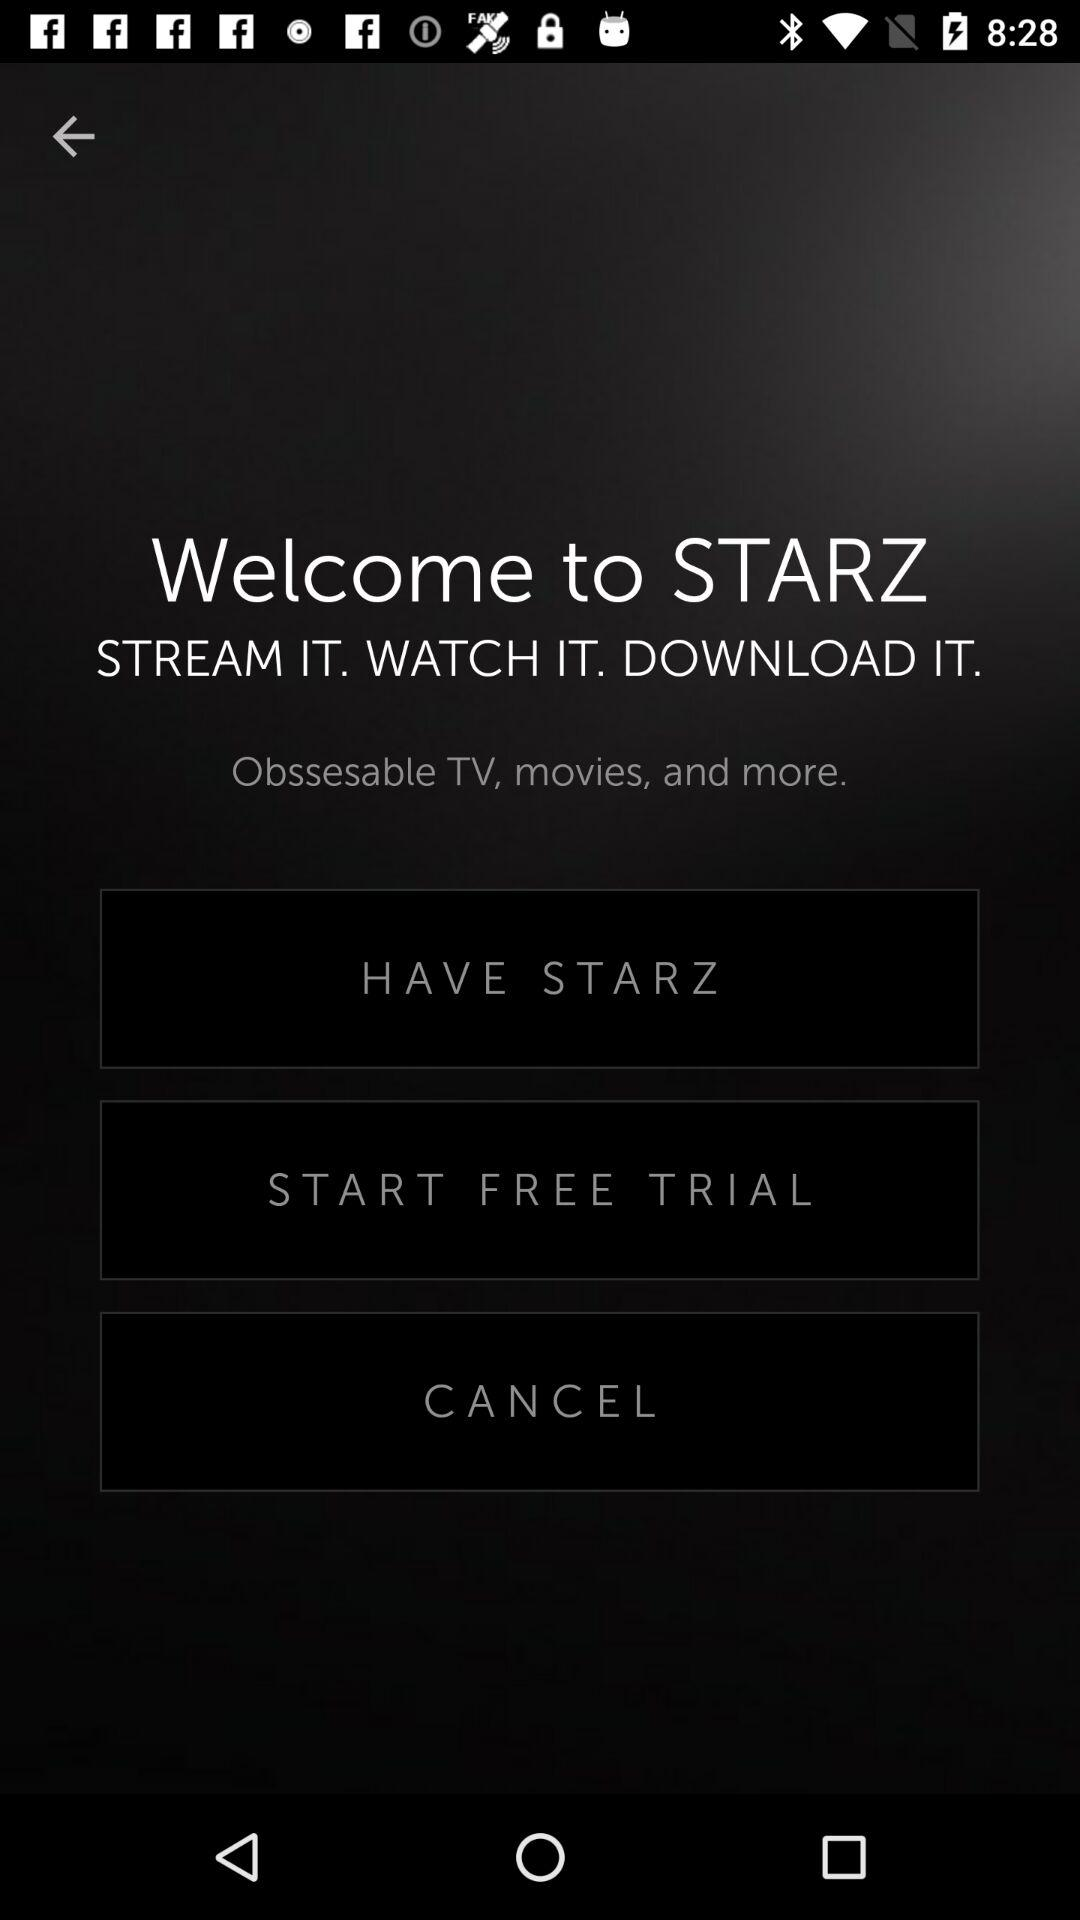What is the application name? The application name is "STARZ". 